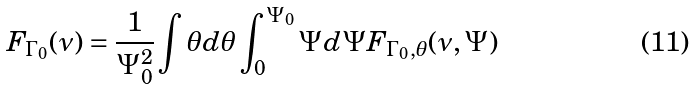Convert formula to latex. <formula><loc_0><loc_0><loc_500><loc_500>F _ { \Gamma _ { 0 } } ( \nu ) = \frac { 1 } { \Psi _ { 0 } ^ { 2 } } \int \theta d \theta \int _ { 0 } ^ { \Psi _ { 0 } } \Psi d \Psi F _ { \Gamma _ { 0 } , \theta } ( \nu , \Psi )</formula> 